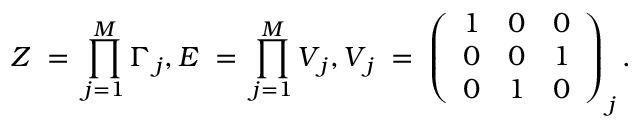Convert formula to latex. <formula><loc_0><loc_0><loc_500><loc_500>Z \, = \, \prod _ { j = 1 } ^ { M } \Gamma _ { \, j } , E \, = \, \prod _ { j = 1 } ^ { M } V _ { \, j } , V _ { \, j } \, = \, \left ( \begin{array} { c c c } { 1 } & { 0 } & { 0 } \\ { 0 } & { 0 } & { 1 } \\ { 0 } & { 1 } & { 0 } \end{array} \right ) _ { \, j } .</formula> 